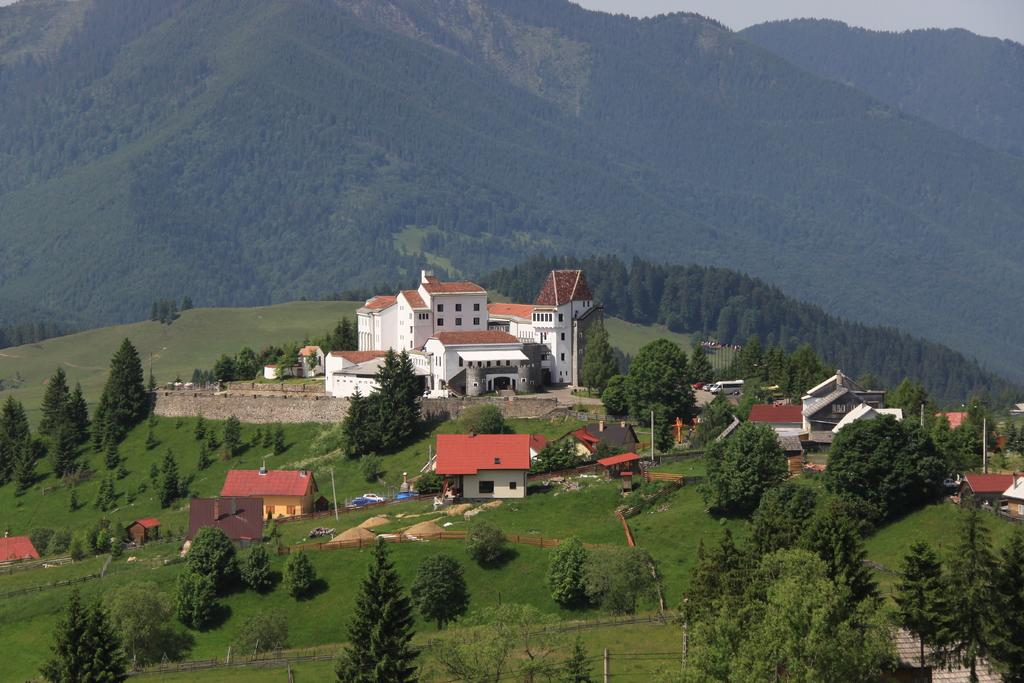What type of structures can be seen in the image? There are buildings in the image. What architectural features can be observed on the buildings? There are windows visible on the buildings. What natural elements are present in the image? There are trees and mountains in the image. What man-made objects can be seen in the image? Vehicles, fencing, and a pole are visible in the image. What type of substance is being sold in the crowd in the image? There is no crowd present in the image, and therefore no substance is being sold. What is the name of the downtown area depicted in the image? The image does not depict a downtown area, so there is no specific name to provide. 